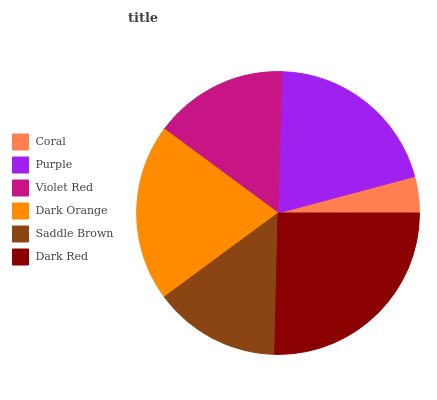Is Coral the minimum?
Answer yes or no. Yes. Is Dark Red the maximum?
Answer yes or no. Yes. Is Purple the minimum?
Answer yes or no. No. Is Purple the maximum?
Answer yes or no. No. Is Purple greater than Coral?
Answer yes or no. Yes. Is Coral less than Purple?
Answer yes or no. Yes. Is Coral greater than Purple?
Answer yes or no. No. Is Purple less than Coral?
Answer yes or no. No. Is Dark Orange the high median?
Answer yes or no. Yes. Is Violet Red the low median?
Answer yes or no. Yes. Is Coral the high median?
Answer yes or no. No. Is Dark Orange the low median?
Answer yes or no. No. 